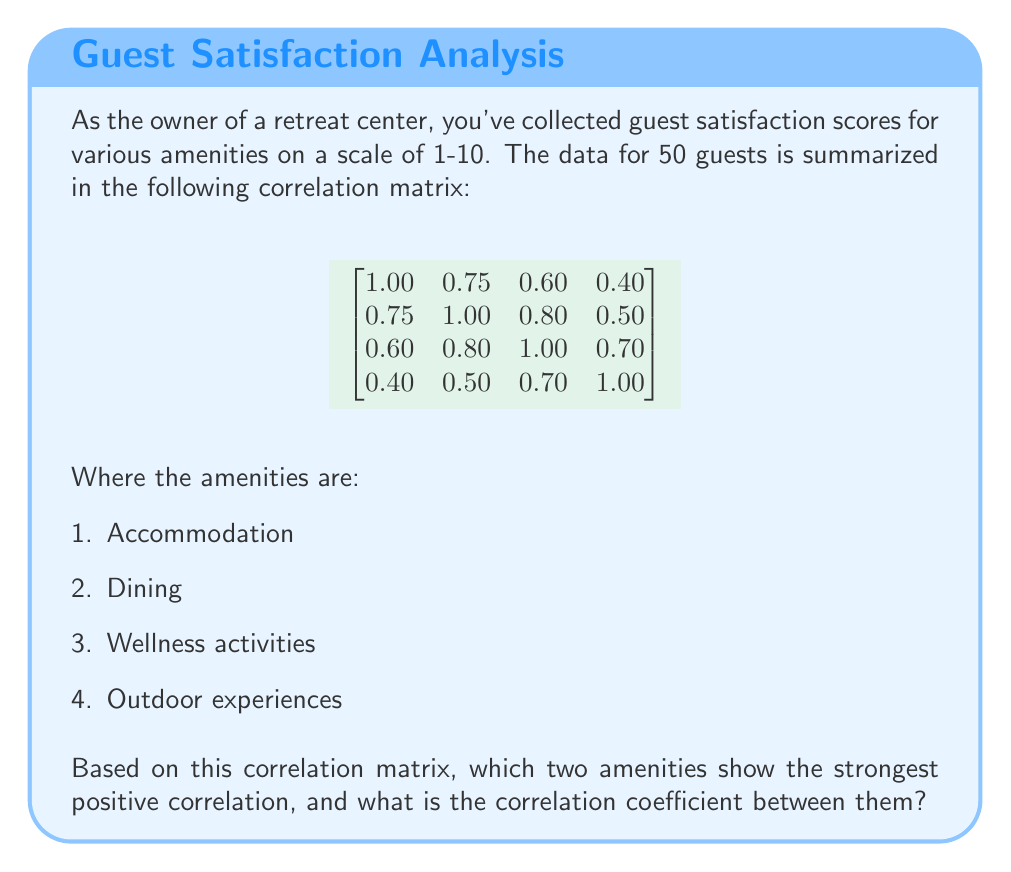Help me with this question. To find the strongest positive correlation between two amenities, we need to examine the off-diagonal elements of the correlation matrix. The correlation coefficient ranges from -1 to 1, where 1 indicates a perfect positive correlation.

Let's analyze the matrix:

1. The diagonal elements are always 1.00, representing the correlation of an amenity with itself.

2. The matrix is symmetric, so we only need to look at the upper or lower triangle.

3. Examining the upper triangle:
   - Correlation between Accommodation and Dining: 0.75
   - Correlation between Accommodation and Wellness: 0.60
   - Correlation between Accommodation and Outdoor: 0.40
   - Correlation between Dining and Wellness: 0.80
   - Correlation between Dining and Outdoor: 0.50
   - Correlation between Wellness and Outdoor: 0.70

4. The highest correlation coefficient is 0.80, which is between Dining (2nd row/column) and Wellness activities (3rd row/column).

Therefore, Dining and Wellness activities show the strongest positive correlation with a coefficient of 0.80.
Answer: Dining and Wellness activities; 0.80 